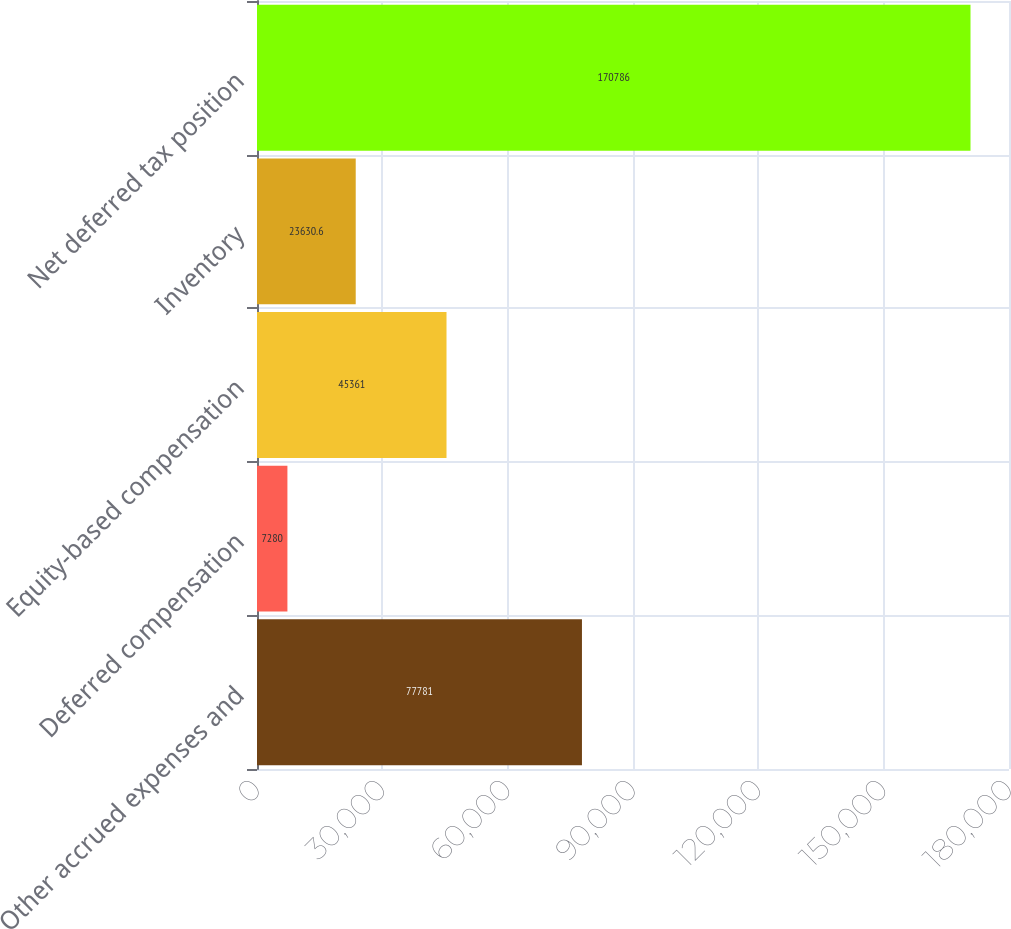Convert chart to OTSL. <chart><loc_0><loc_0><loc_500><loc_500><bar_chart><fcel>Other accrued expenses and<fcel>Deferred compensation<fcel>Equity-based compensation<fcel>Inventory<fcel>Net deferred tax position<nl><fcel>77781<fcel>7280<fcel>45361<fcel>23630.6<fcel>170786<nl></chart> 